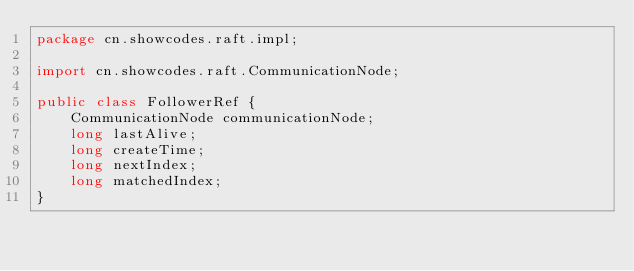<code> <loc_0><loc_0><loc_500><loc_500><_Java_>package cn.showcodes.raft.impl;

import cn.showcodes.raft.CommunicationNode;

public class FollowerRef {
    CommunicationNode communicationNode;
    long lastAlive;
    long createTime;
    long nextIndex;
    long matchedIndex;
}
</code> 